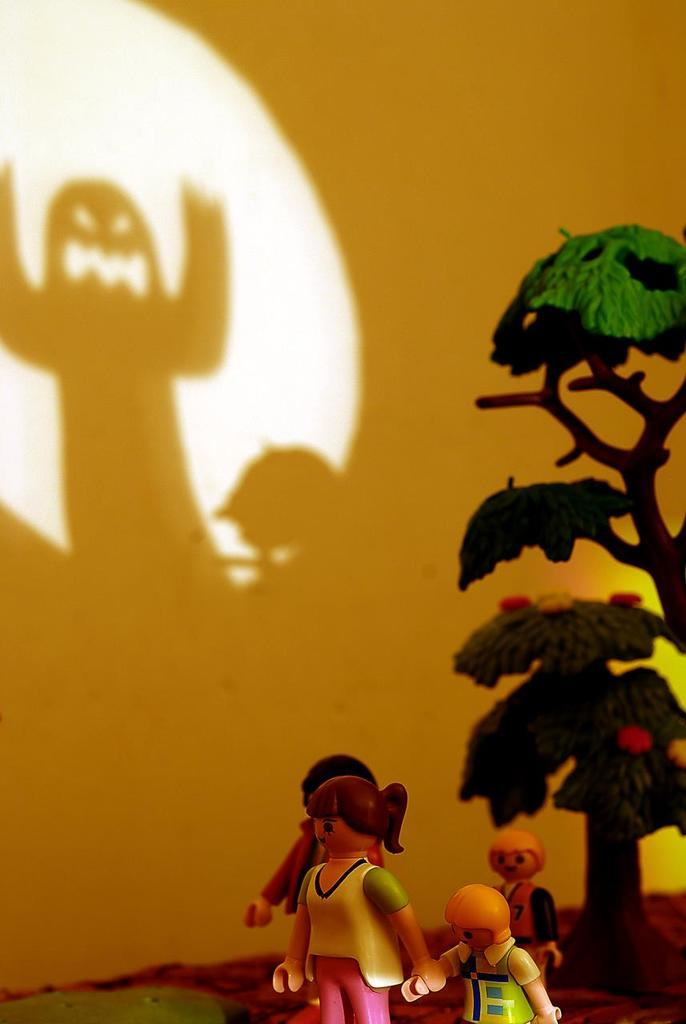What objects can be seen in the image? There are toys in the image. Can you describe the appearance of the toys? The toys are multi-colored. What can be seen in the background of the image? There are trees and a wall in the background of the image. How would you describe the trees in the background? The trees are green. What color is the wall in the background? The wall is yellow. How does the worm interact with the toys in the image? There is no worm present in the image, so it cannot interact with the toys. 